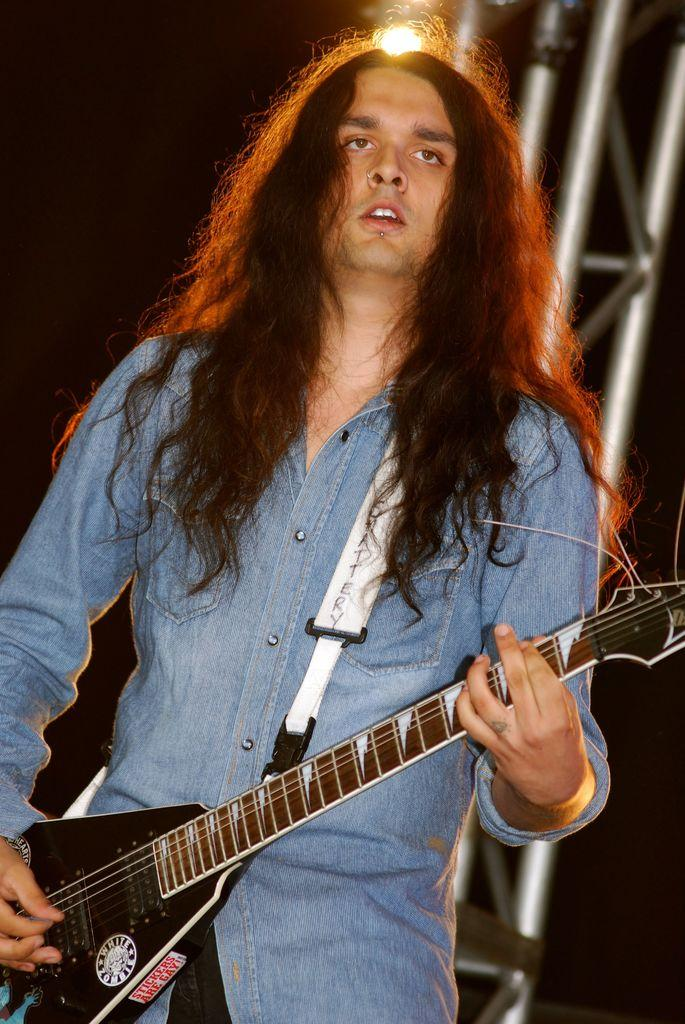Who or what is the main subject in the image? There is a person in the image. What is the person wearing? The person is wearing a blue shirt. What is the person holding in the image? The person is holding a guitar. What can be seen in the background of the image? There are metal rods and a light in the background of the image. What type of tray is the person using to rub the guitar in the image? There is no tray present in the image, and the person is not rubbing the guitar. 